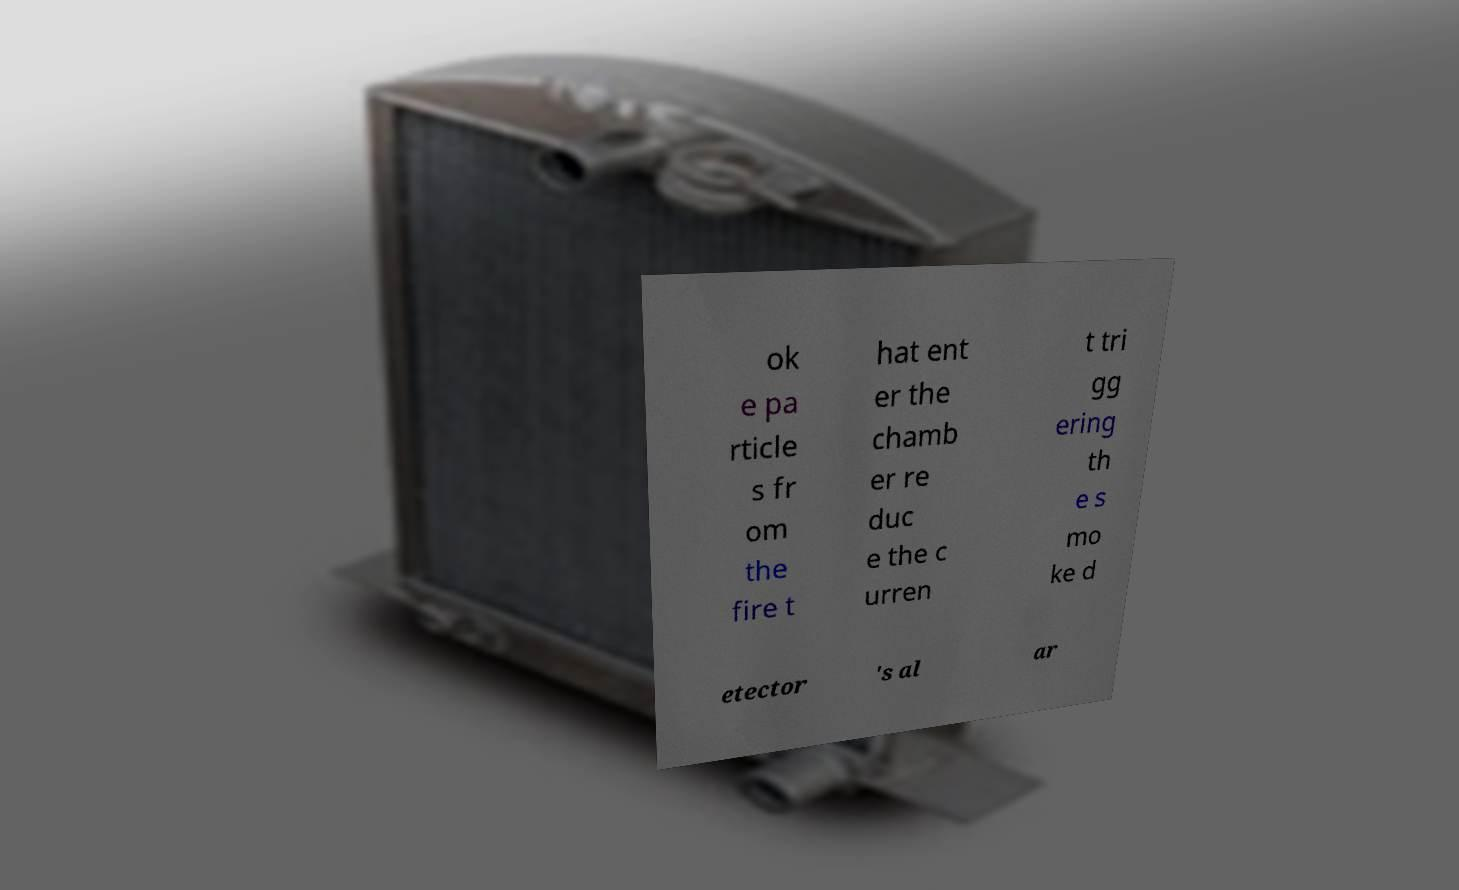Can you read and provide the text displayed in the image?This photo seems to have some interesting text. Can you extract and type it out for me? ok e pa rticle s fr om the fire t hat ent er the chamb er re duc e the c urren t tri gg ering th e s mo ke d etector 's al ar 